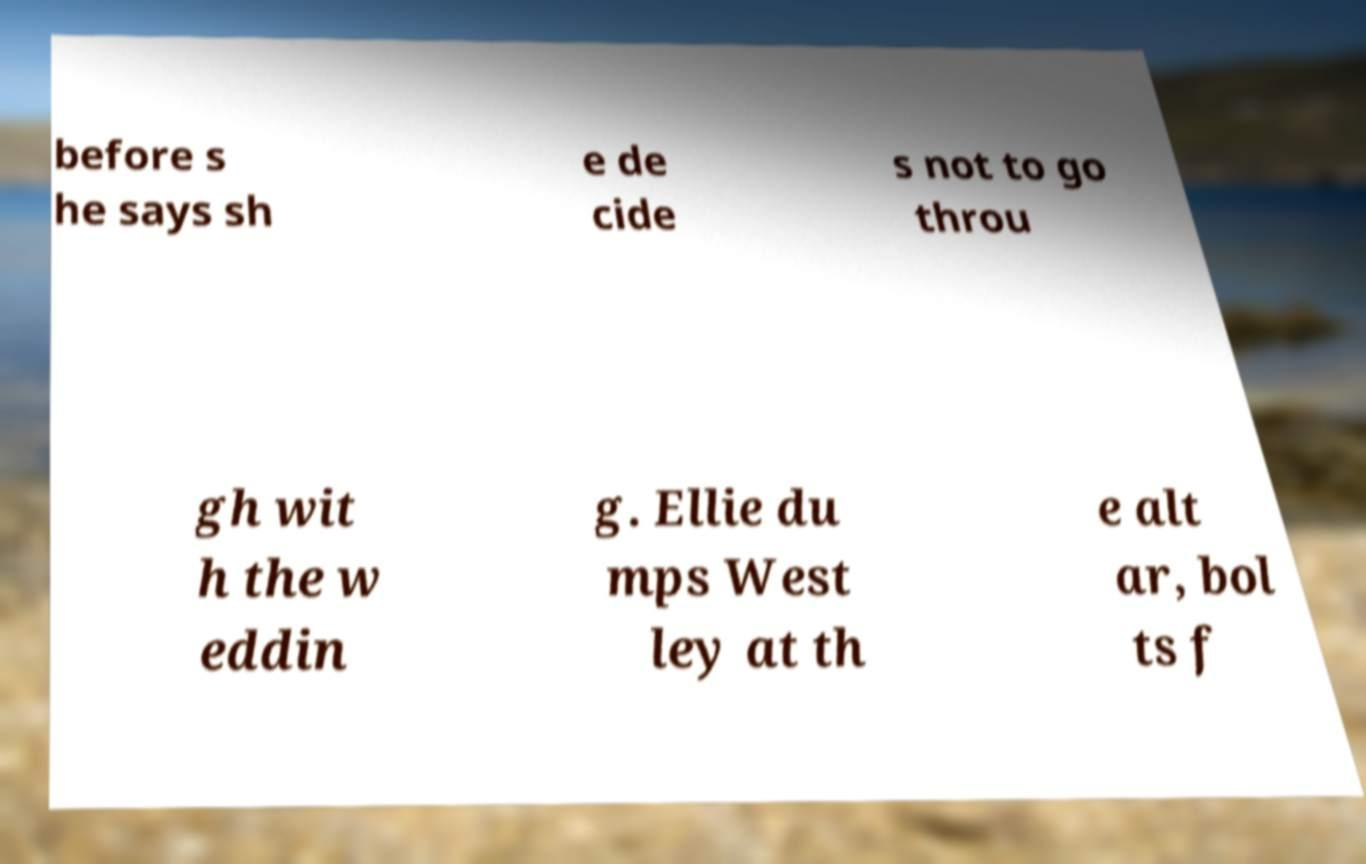Please read and relay the text visible in this image. What does it say? before s he says sh e de cide s not to go throu gh wit h the w eddin g. Ellie du mps West ley at th e alt ar, bol ts f 